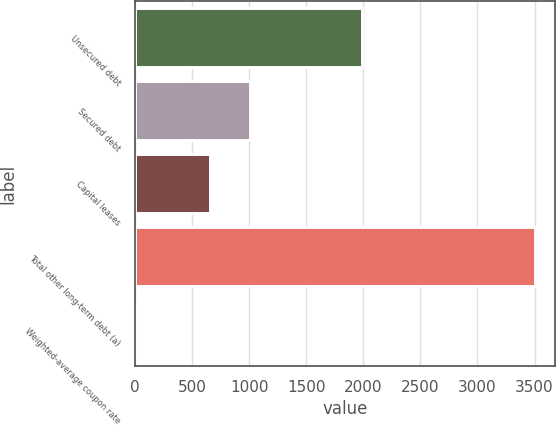<chart> <loc_0><loc_0><loc_500><loc_500><bar_chart><fcel>Unsecured debt<fcel>Secured debt<fcel>Capital leases<fcel>Total other long-term debt (a)<fcel>Weighted-average coupon rate<nl><fcel>1985<fcel>1004.43<fcel>654<fcel>3507<fcel>2.7<nl></chart> 